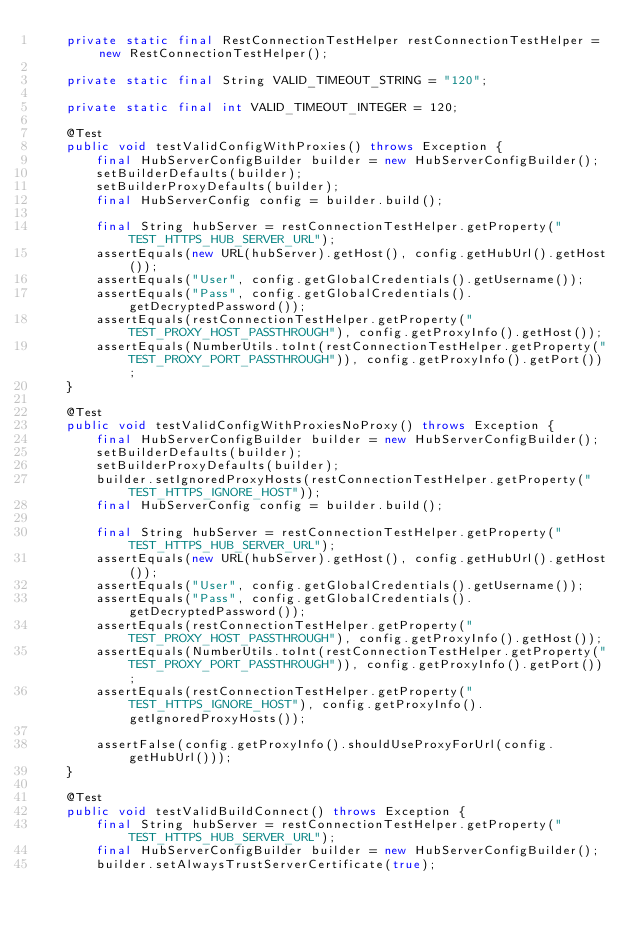<code> <loc_0><loc_0><loc_500><loc_500><_Java_>    private static final RestConnectionTestHelper restConnectionTestHelper = new RestConnectionTestHelper();

    private static final String VALID_TIMEOUT_STRING = "120";

    private static final int VALID_TIMEOUT_INTEGER = 120;

    @Test
    public void testValidConfigWithProxies() throws Exception {
        final HubServerConfigBuilder builder = new HubServerConfigBuilder();
        setBuilderDefaults(builder);
        setBuilderProxyDefaults(builder);
        final HubServerConfig config = builder.build();

        final String hubServer = restConnectionTestHelper.getProperty("TEST_HTTPS_HUB_SERVER_URL");
        assertEquals(new URL(hubServer).getHost(), config.getHubUrl().getHost());
        assertEquals("User", config.getGlobalCredentials().getUsername());
        assertEquals("Pass", config.getGlobalCredentials().getDecryptedPassword());
        assertEquals(restConnectionTestHelper.getProperty("TEST_PROXY_HOST_PASSTHROUGH"), config.getProxyInfo().getHost());
        assertEquals(NumberUtils.toInt(restConnectionTestHelper.getProperty("TEST_PROXY_PORT_PASSTHROUGH")), config.getProxyInfo().getPort());
    }

    @Test
    public void testValidConfigWithProxiesNoProxy() throws Exception {
        final HubServerConfigBuilder builder = new HubServerConfigBuilder();
        setBuilderDefaults(builder);
        setBuilderProxyDefaults(builder);
        builder.setIgnoredProxyHosts(restConnectionTestHelper.getProperty("TEST_HTTPS_IGNORE_HOST"));
        final HubServerConfig config = builder.build();

        final String hubServer = restConnectionTestHelper.getProperty("TEST_HTTPS_HUB_SERVER_URL");
        assertEquals(new URL(hubServer).getHost(), config.getHubUrl().getHost());
        assertEquals("User", config.getGlobalCredentials().getUsername());
        assertEquals("Pass", config.getGlobalCredentials().getDecryptedPassword());
        assertEquals(restConnectionTestHelper.getProperty("TEST_PROXY_HOST_PASSTHROUGH"), config.getProxyInfo().getHost());
        assertEquals(NumberUtils.toInt(restConnectionTestHelper.getProperty("TEST_PROXY_PORT_PASSTHROUGH")), config.getProxyInfo().getPort());
        assertEquals(restConnectionTestHelper.getProperty("TEST_HTTPS_IGNORE_HOST"), config.getProxyInfo().getIgnoredProxyHosts());

        assertFalse(config.getProxyInfo().shouldUseProxyForUrl(config.getHubUrl()));
    }

    @Test
    public void testValidBuildConnect() throws Exception {
        final String hubServer = restConnectionTestHelper.getProperty("TEST_HTTPS_HUB_SERVER_URL");
        final HubServerConfigBuilder builder = new HubServerConfigBuilder();
        builder.setAlwaysTrustServerCertificate(true);</code> 